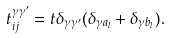Convert formula to latex. <formula><loc_0><loc_0><loc_500><loc_500>t _ { i j } ^ { \gamma \gamma ^ { \prime } } = t \delta _ { \gamma \gamma ^ { \prime } } ( \delta _ { \gamma a _ { l } } + \delta _ { \gamma b _ { l } } ) .</formula> 